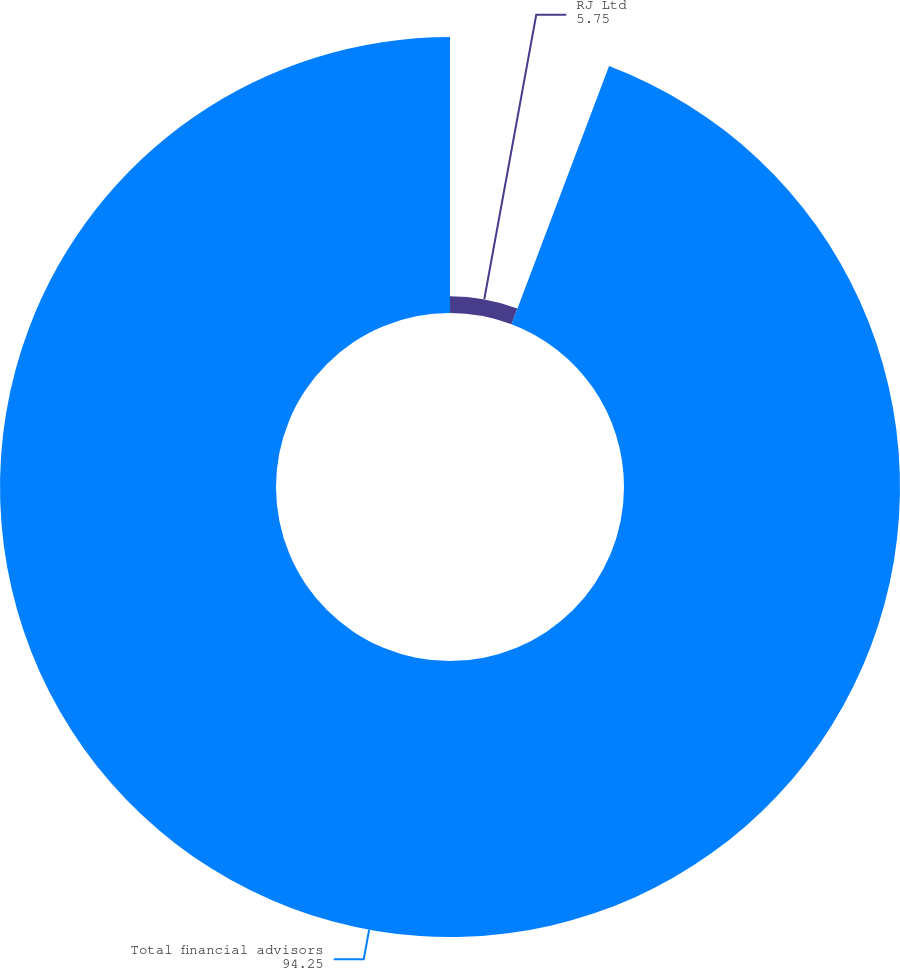Convert chart to OTSL. <chart><loc_0><loc_0><loc_500><loc_500><pie_chart><fcel>RJ Ltd<fcel>Total financial advisors<nl><fcel>5.75%<fcel>94.25%<nl></chart> 